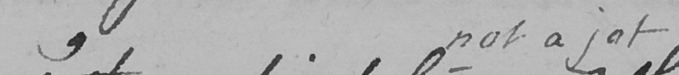Can you read and transcribe this handwriting? , not a jot 